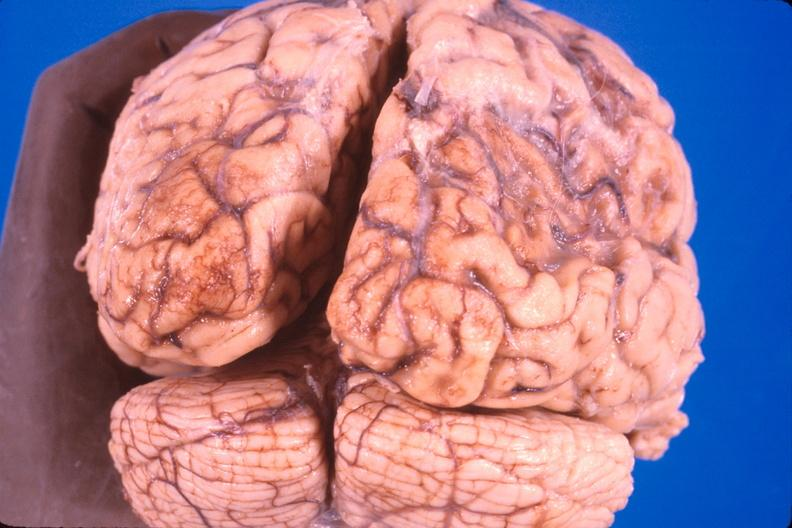s nervous present?
Answer the question using a single word or phrase. Yes 